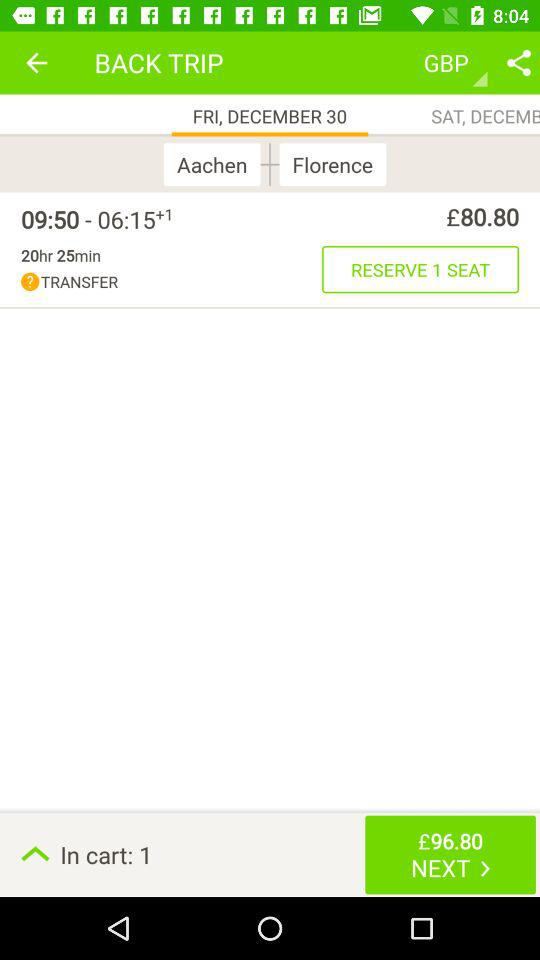How many seats can be reserved? There can be 1 seat reserved. 